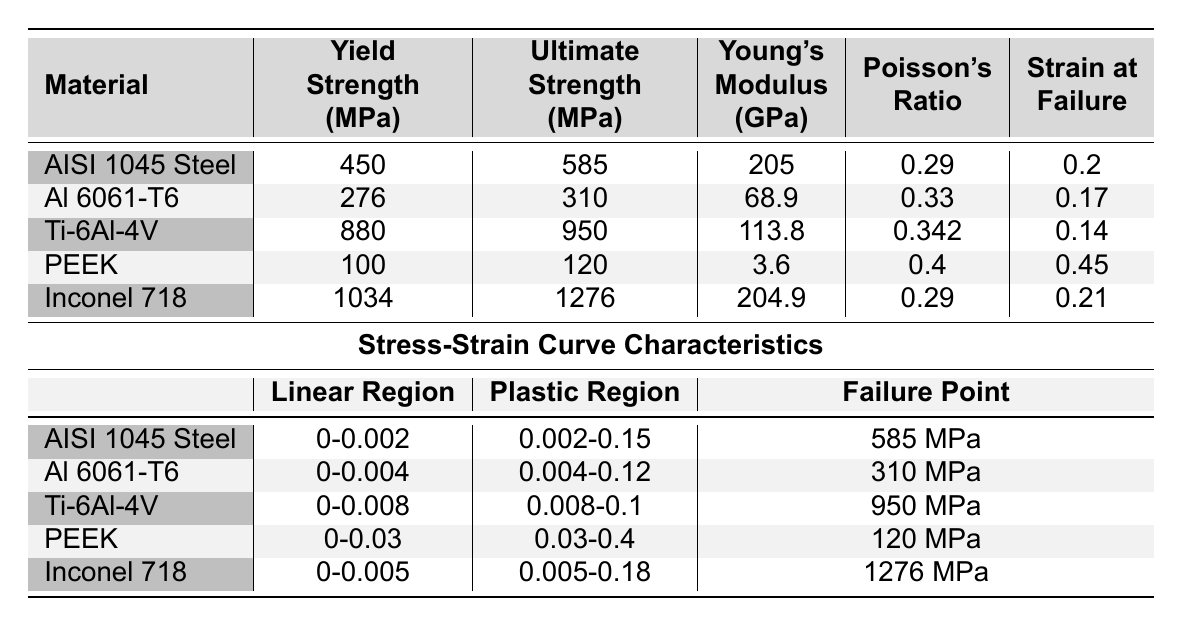What is the yield strength of AISI 1045 Steel? The yield strength is listed in the table under the column "Yield Strength (MPa)" for the row corresponding to AISI 1045 Steel, which is 450 MPa.
Answer: 450 MPa Which material has the highest ultimate strength? To find this, compare the "Ultimate Strength (MPa)" values for each material listed in the table. Inconel 718 has the highest value at 1276 MPa.
Answer: Inconel 718 What is the strain at failure for Ti-6Al-4V? The strain at failure is specified in the "Strain at Failure" column for Ti-6Al-4V, which shows a value of 0.14.
Answer: 0.14 Is the Poisson's ratio for PEEK greater than that of Al 6061-T6? The Poisson's ratio for PEEK is 0.4, while for Al 6061-T6 it is 0.33. Since 0.4 is greater than 0.33, the statement is true.
Answer: Yes What is the difference in yield strength between Inconel 718 and Al 6061-T6? The yield strength for Inconel 718 is 1034 MPa and for Al 6061-T6 it is 276 MPa. The difference is calculated as 1034 - 276 = 758 MPa.
Answer: 758 MPa What is the average Young's Modulus of all materials in the table? Calculate the average by summing the Young's Modulus values: 205 + 68.9 + 113.8 + 3.6 + 204.9 = 596.2 GPa. There are 5 materials, so the average is 596.2 / 5 = 119.24 GPa.
Answer: 119.24 GPa Which material has the longest plastic region? The length of the plastic region can be inferred from the ranges given in the "Plastic Region" column. PEEK has the range 0.03-0.4, representing a length of 0.37, which is longer than the other materials.
Answer: PEEK If we combine the yield strengths of AISI 1045 Steel and Ti-6Al-4V, what is the total yield strength? Adding the yield strengths: 450 MPa (AISI 1045 Steel) + 880 MPa (Ti-6Al-4V) = 1330 MPa.
Answer: 1330 MPa Is the Young’s Modulus for Al 6061-T6 less than that for PEEK? The Young's Modulus for Al 6061-T6 is 68.9 GPa and for PEEK it is 3.6 GPa. Since 68.9 is greater than 3.6, the statement is false.
Answer: No What is the strain at failure for the material with the highest yield strength? The material with the highest yield strength is Ti-6Al-4V with a yield strength of 880 MPa. Its strain at failure is given as 0.14, which corresponds to the same row.
Answer: 0.14 